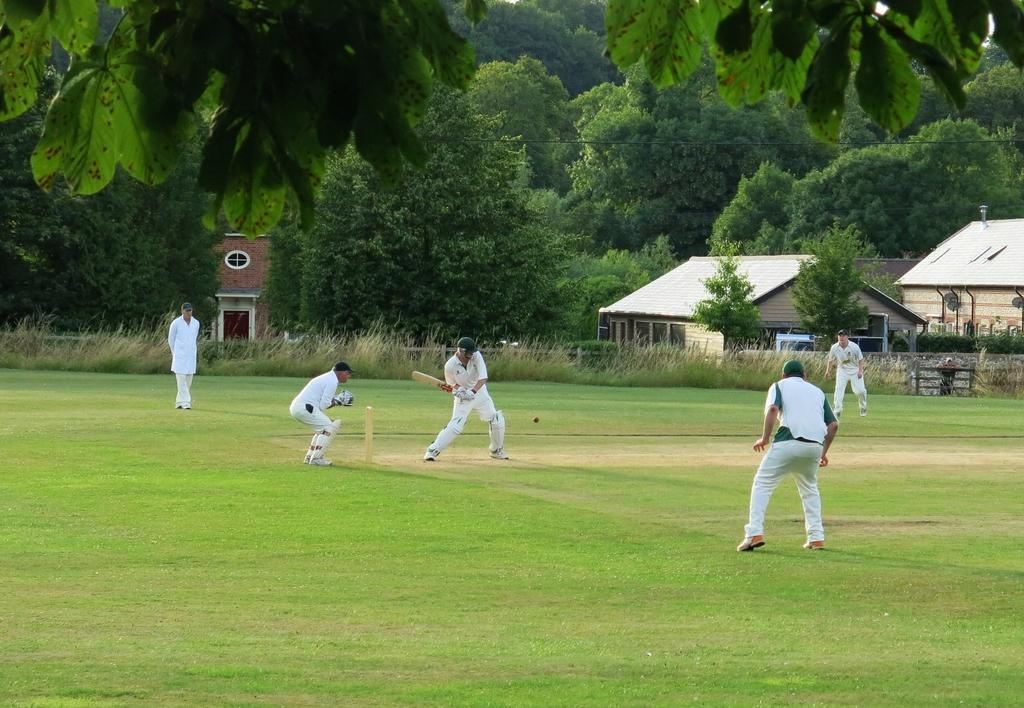What are the persons in the image wearing? The persons in the image are wearing white color dresses. What sport are the persons playing in the image? The persons are playing cricket in the image. Where is the cricket being played? The cricket is being played on a ground in the image. What is the condition of the ground? The ground has grass in the image. What can be seen in the background of the image? There are buildings and trees in the background of the image. Can you see any wounds on the persons playing cricket in the image? There is no indication of any wounds on the persons playing cricket in the image. What type of glass is being used to play the game in the image? There is no glass being used to play the game in the image; cricket is played with a ball and a bat. 